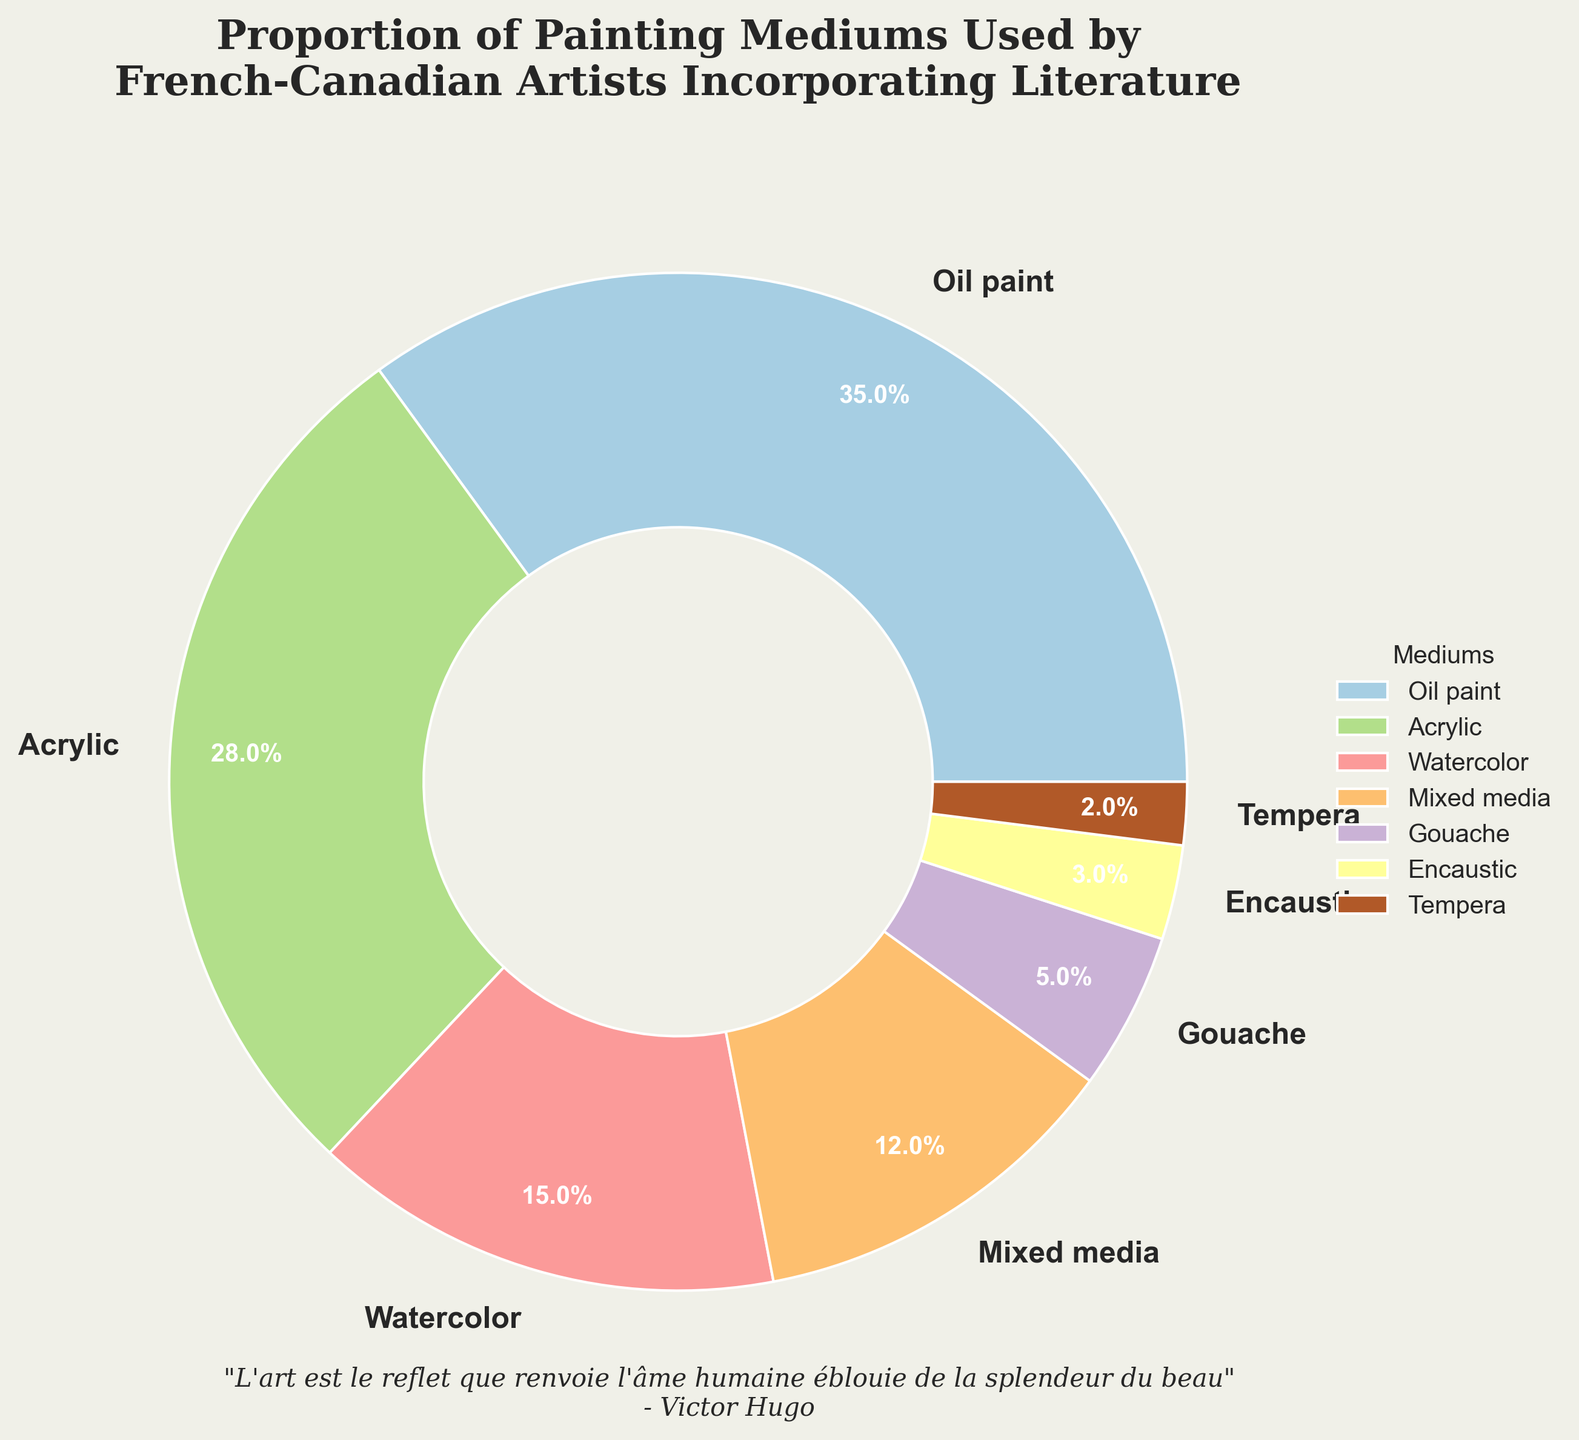What is the most used painting medium by French-Canadian artists incorporating literature? By looking at the pie chart, the largest portion corresponds to oil paint with 35%, making it the most used medium.
Answer: Oil paint Which painting medium is used more, acrylic or watercolor? By comparing the percentages in the chart, acrylic is 28% and watercolor is 15%. Therefore, acrylic is used more.
Answer: Acrylic What is the combined percentage of gouache and encaustic mediums? The chart shows that gouache is 5% and encaustic is 3%. Adding these together gives 5 + 3 = 8%.
Answer: 8% How many mediums have a usage percentage of at least 10%? The mediums with at least 10% usage are oil paint (35%), acrylic (28%), watercolor (15%), and mixed media (12%). Thus, 4 mediums meet this criterion.
Answer: 4 Which medium has the smallest usage percentage? The smallest portion in the pie chart is tempera with 2%.
Answer: Tempera Is the percentage of oil paint usage greater than the combined usage percentage of watercolor and mixed media? Oil paint usage is 35%. Combined usage of watercolor (15%) and mixed media (12%) is 15 + 12 = 27%. Since 35% is greater than 27%, oil paint usage is indeed greater.
Answer: Yes What is the difference in percentage between the most used and the least used mediums? The most used medium is oil paint at 35%, and the least used is tempera at 2%. The difference is 35 - 2 = 33%.
Answer: 33% Between gouache and acrylic mediums, which one occupies a larger segment visually in terms of color? By looking at the respective segments in the pie chart, gouache is 5% while acrylic is 28%. Clearly, acrylic occupies a larger segment visually.
Answer: Acrylic If you were to group all mediums with less than 10% usage, what percentage of total usage would they represent? Mediums with less than 10% usage are gouache (5%), encaustic (3%), and tempera (2%). Their total usage percentage is 5 + 3 + 2 = 10%.
Answer: 10% Are there more mediums with a usage percentage greater than or equal to 10%, or those with less than 10%? Mediums with greater than or equal to 10% usage are oil paint (35%), acrylic (28%), watercolor (15%), and mixed media (12%) — making 4 mediums. Those with less than 10% are gouache (5%), encaustic (3%), and tempera (2%) — making 3 mediums. Thus, there are more mediums with usage percentages greater than or equal to 10%.
Answer: Greater than or equal to 10% 